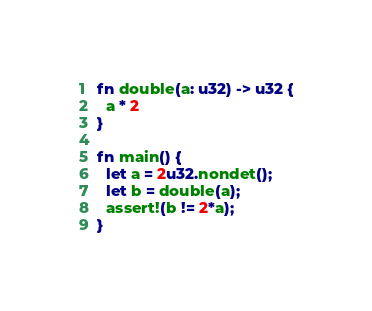Convert code to text. <code><loc_0><loc_0><loc_500><loc_500><_Rust_>
fn double(a: u32) -> u32 {
  a * 2
}

fn main() {
  let a = 2u32.nondet();
  let b = double(a);
  assert!(b != 2*a);
}
</code> 